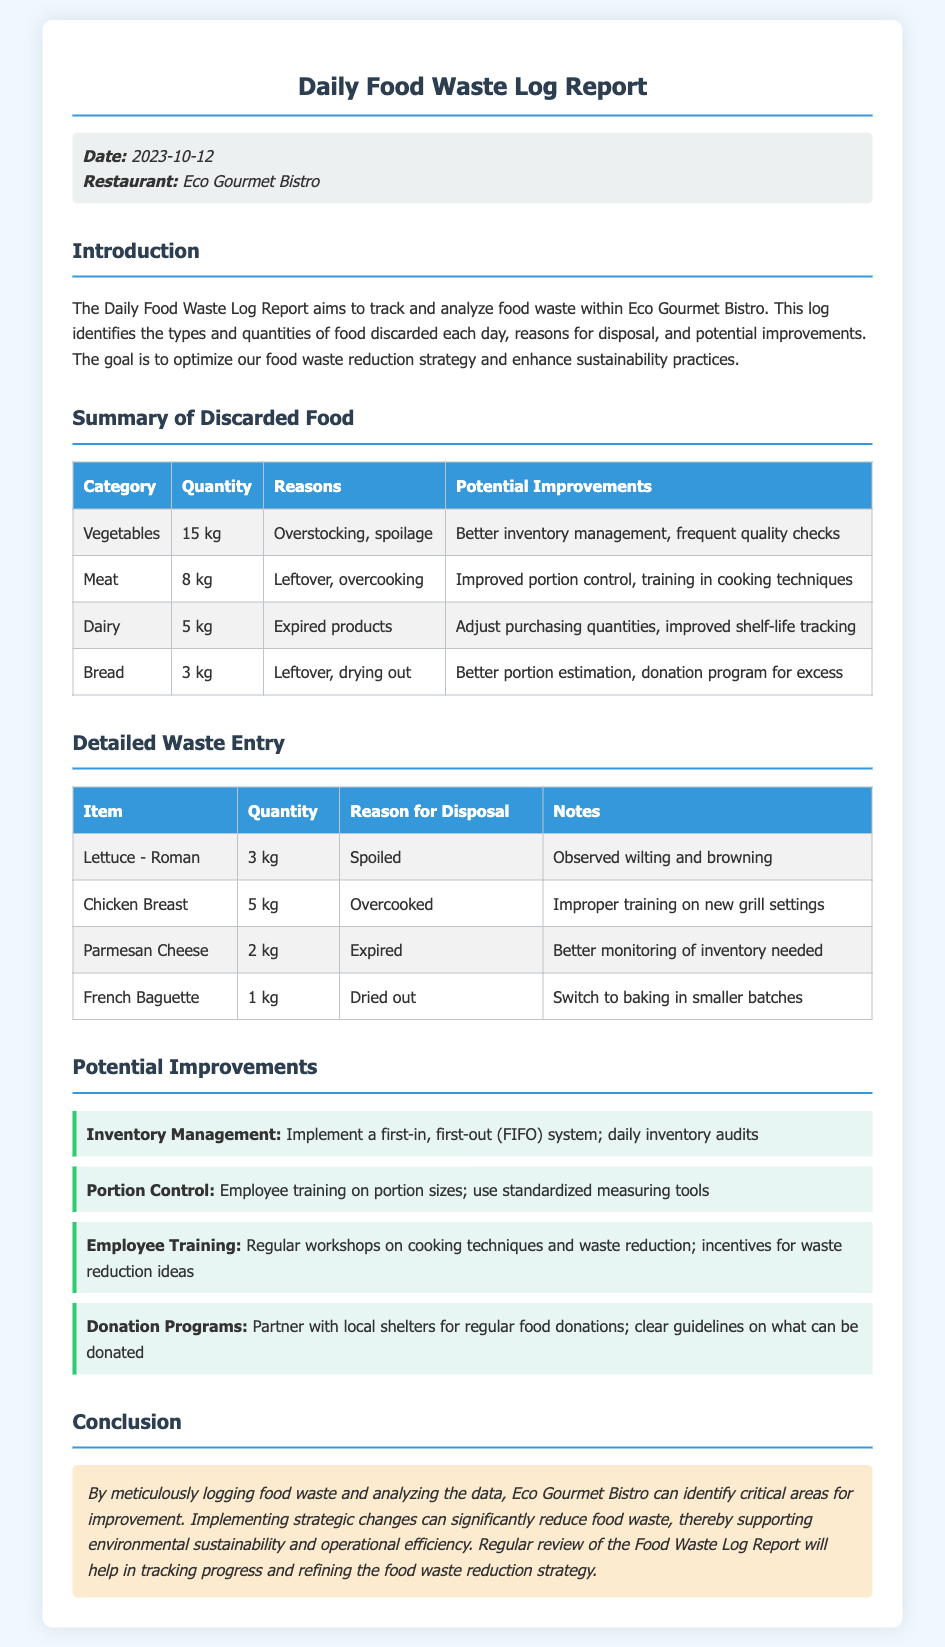what date is the report for? The date of the report is specified in the meta-info section of the document.
Answer: 2023-10-12 how many kilograms of vegetables were discarded? The quantity of vegetables discarded is listed in the Summary of Discarded Food table.
Answer: 15 kg what was the reason for discarding the chicken breast? The reason for disposal of the chicken breast is provided in the Detailed Waste Entry table.
Answer: Overcooked what is one potential improvement for the dairy waste? The potential improvements for the dairy waste are listed in the Summary of Discarded Food table.
Answer: Adjust purchasing quantities how many kilograms of bread were discarded? The quantity of bread discarded is shown in the Summary of Discarded Food table.
Answer: 3 kg what was one specific reason for the spoilage of lettuce? The reason for the spoilage of lettuce is mentioned in the Detailed Waste Entry table.
Answer: Spoiled what type of document is this? The report provides a specific format for tracking food waste, indicating its purpose.
Answer: Daily Food Waste Log Report how many kilograms of expired dairy products were discarded? The quantity of expired dairy products discarded is specified in the Detailed Waste Entry table.
Answer: 2 kg which category has the least waste? The category with the least amount of waste can be found in the Summary of Discarded Food table.
Answer: Bread 